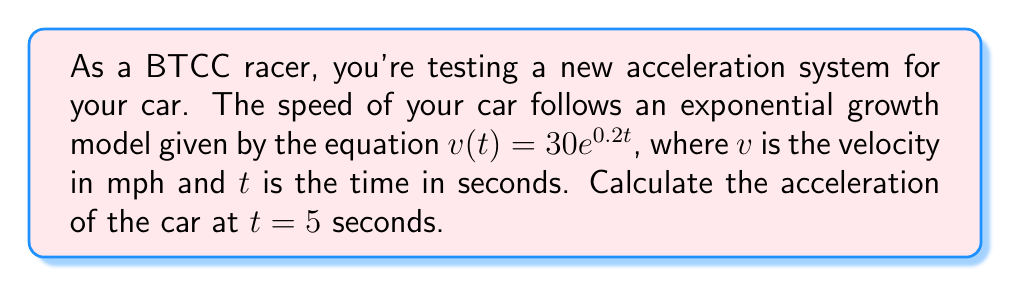Can you solve this math problem? To solve this problem, we need to follow these steps:

1) The acceleration is the rate of change of velocity with respect to time. In mathematical terms, it's the derivative of the velocity function.

2) Given: $v(t) = 30e^{0.2t}$

3) To find acceleration, we need to differentiate $v(t)$ with respect to $t$:

   $$\frac{d}{dt}v(t) = \frac{d}{dt}(30e^{0.2t})$$

4) Using the chain rule:

   $$\frac{d}{dt}v(t) = 30 \cdot 0.2 \cdot e^{0.2t} = 6e^{0.2t}$$

5) This gives us the acceleration function $a(t) = 6e^{0.2t}$

6) To find the acceleration at $t = 5$ seconds, we substitute $t = 5$ into this function:

   $$a(5) = 6e^{0.2(5)} = 6e^1 = 6 \cdot 2.71828... \approx 16.31$$

7) The units of acceleration are mph/s (miles per hour per second).
Answer: The acceleration of the car at $t = 5$ seconds is approximately 16.31 mph/s. 